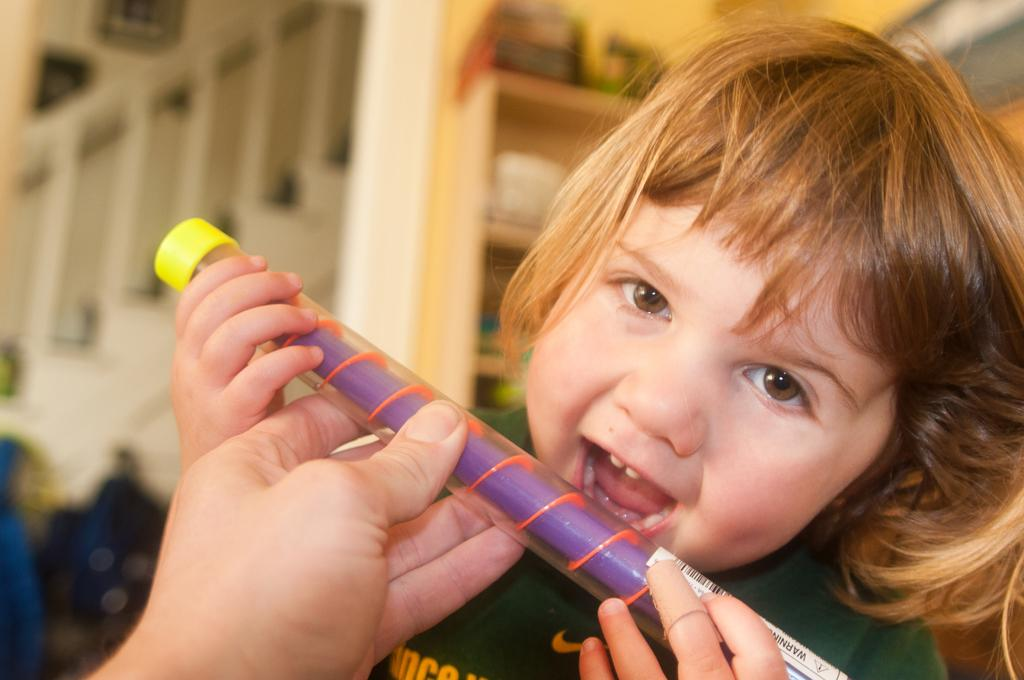What is the main subject of the image? The main subject of the image is a kid. What is the kid doing in the image? The kid is playing with a toy. What can be seen in the background of the image? There are cupboards and stairs in the background of the image. How many items are on the list in the image? There is no list present in the image. 